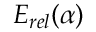Convert formula to latex. <formula><loc_0><loc_0><loc_500><loc_500>E _ { r e l } ( \alpha )</formula> 